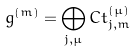Convert formula to latex. <formula><loc_0><loc_0><loc_500><loc_500>g ^ { ( m ) } = \bigoplus _ { j , \mu } C t _ { j , m } ^ { ( \mu ) }</formula> 